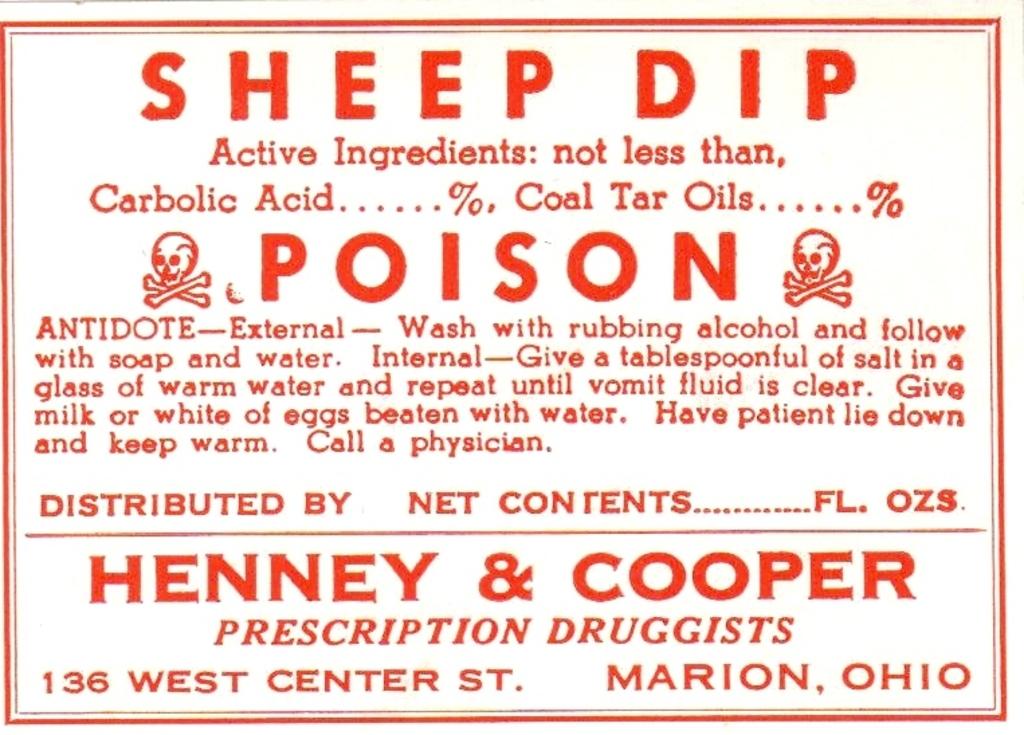What are henney and cooper?
Offer a very short reply. Prescription druggists. What is the address?
Give a very brief answer. 136 west center st. marion, oh. 